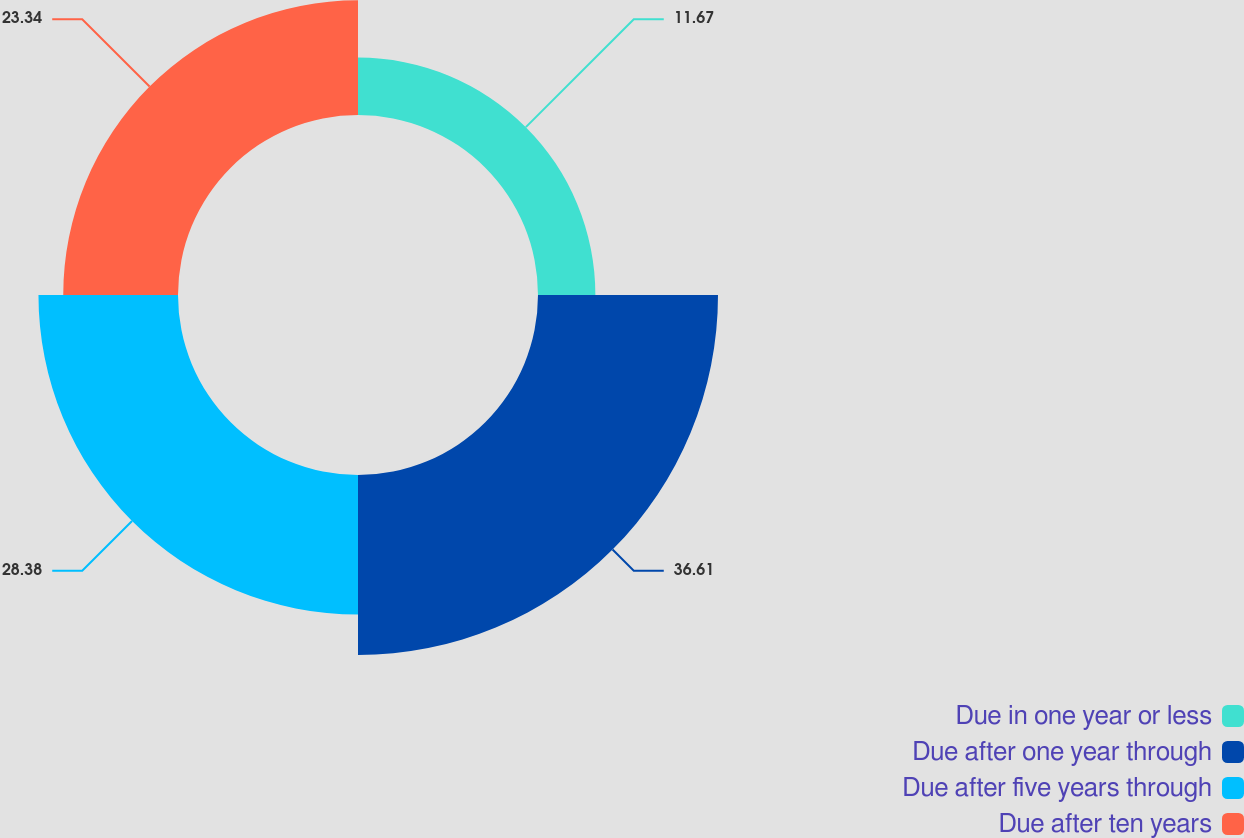<chart> <loc_0><loc_0><loc_500><loc_500><pie_chart><fcel>Due in one year or less<fcel>Due after one year through<fcel>Due after five years through<fcel>Due after ten years<nl><fcel>11.67%<fcel>36.61%<fcel>28.38%<fcel>23.34%<nl></chart> 